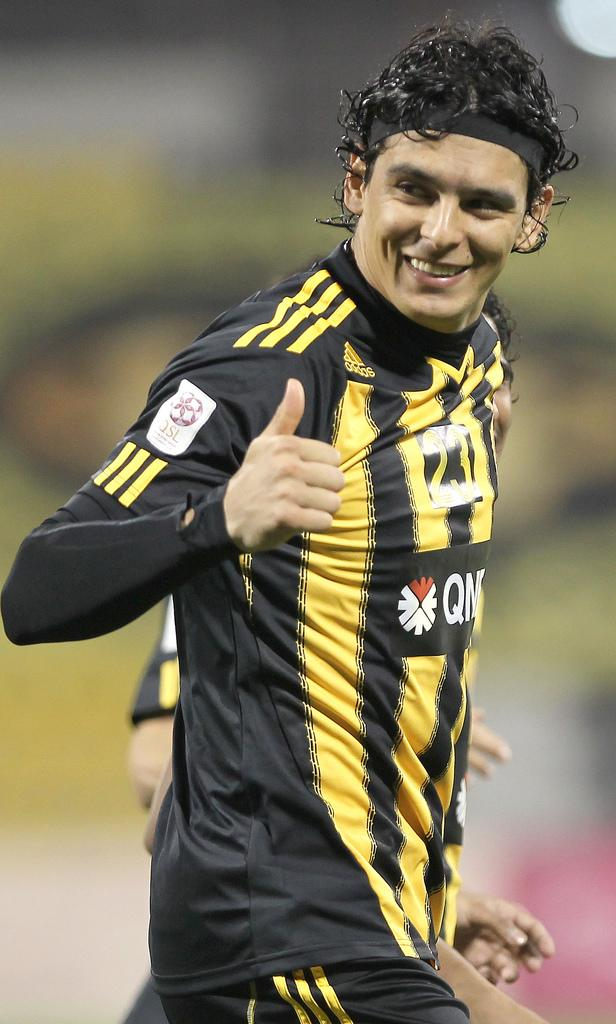What is the man in the image wearing? The man is wearing a black jersey. What expression does the man have in the image? The man is smiling. Can you describe the person behind the man in the image? There is another person behind the man, but their appearance is not clear from the provided facts. How would you describe the background of the image? The background is blurred. Where is the kitten playing with the rail in the image? There is no kitten or rail present in the image. What type of front is visible in the image? The provided facts do not mention any specific front or facade in the image. 